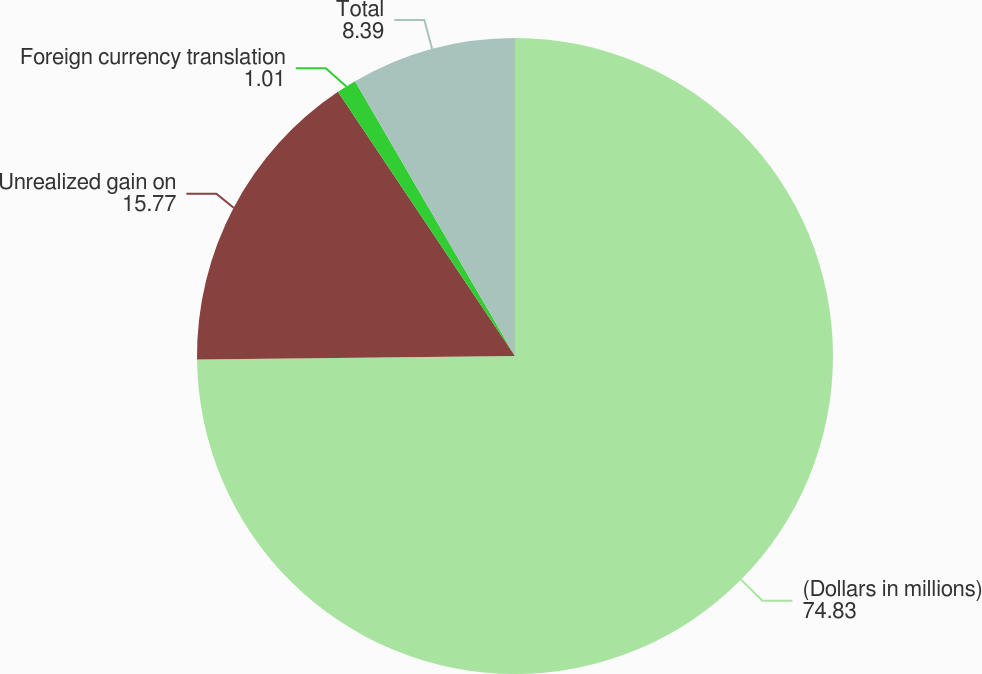Convert chart to OTSL. <chart><loc_0><loc_0><loc_500><loc_500><pie_chart><fcel>(Dollars in millions)<fcel>Unrealized gain on<fcel>Foreign currency translation<fcel>Total<nl><fcel>74.83%<fcel>15.77%<fcel>1.01%<fcel>8.39%<nl></chart> 